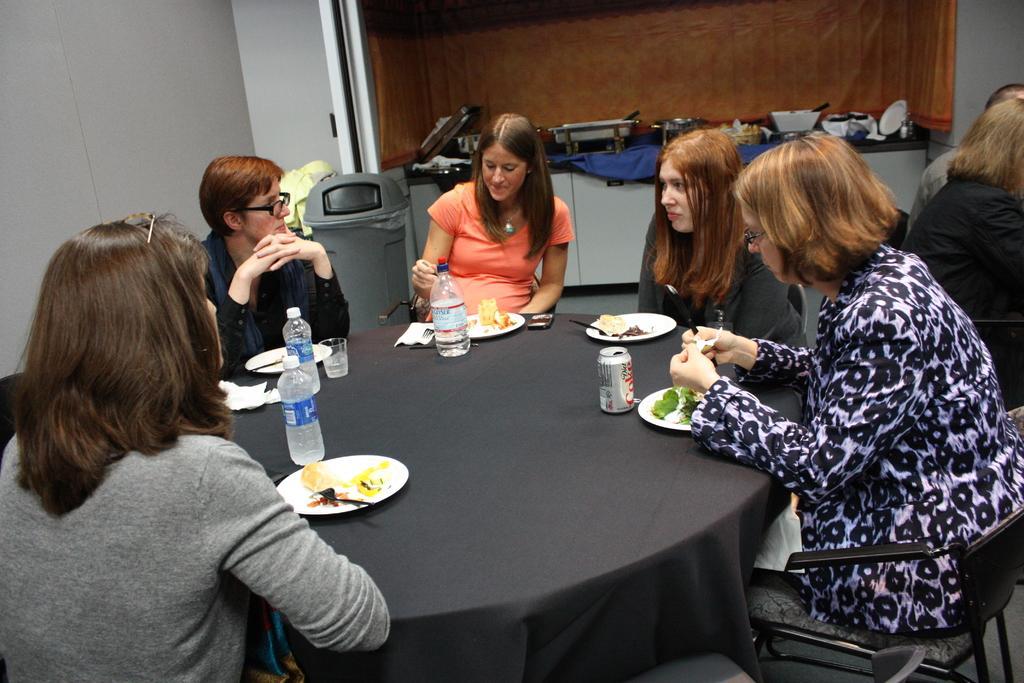Describe this image in one or two sentences. In this image we can see a group of people sitting on the chair. On the table there are plate,spoon,bottle,cup and food. At the back side there is a bin. 